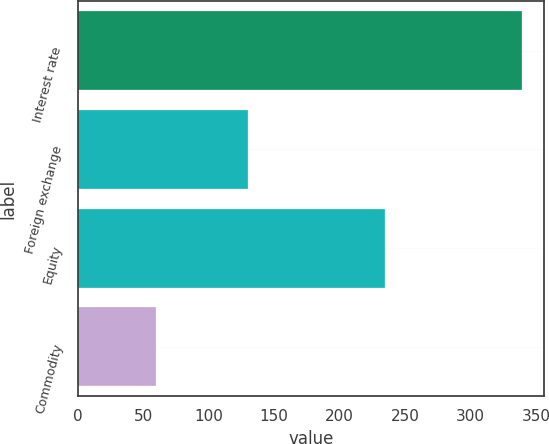<chart> <loc_0><loc_0><loc_500><loc_500><bar_chart><fcel>Interest rate<fcel>Foreign exchange<fcel>Equity<fcel>Commodity<nl><fcel>339<fcel>130<fcel>235<fcel>60<nl></chart> 